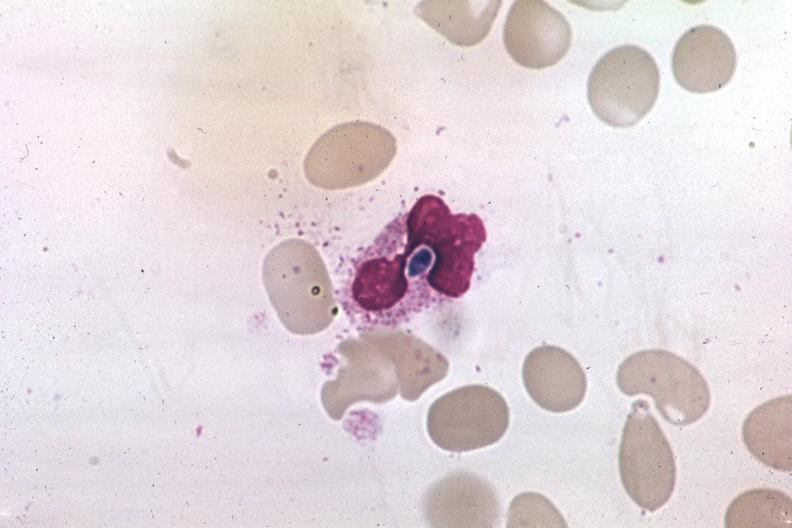what is present?
Answer the question using a single word or phrase. Blood 